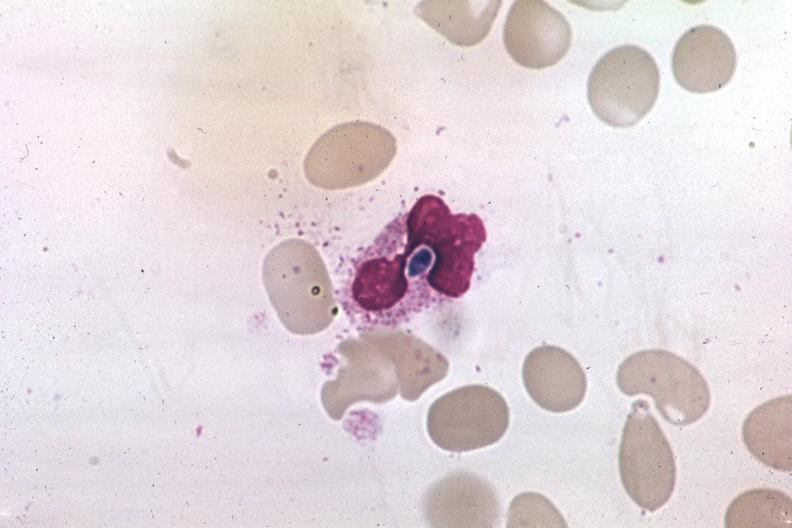what is present?
Answer the question using a single word or phrase. Blood 